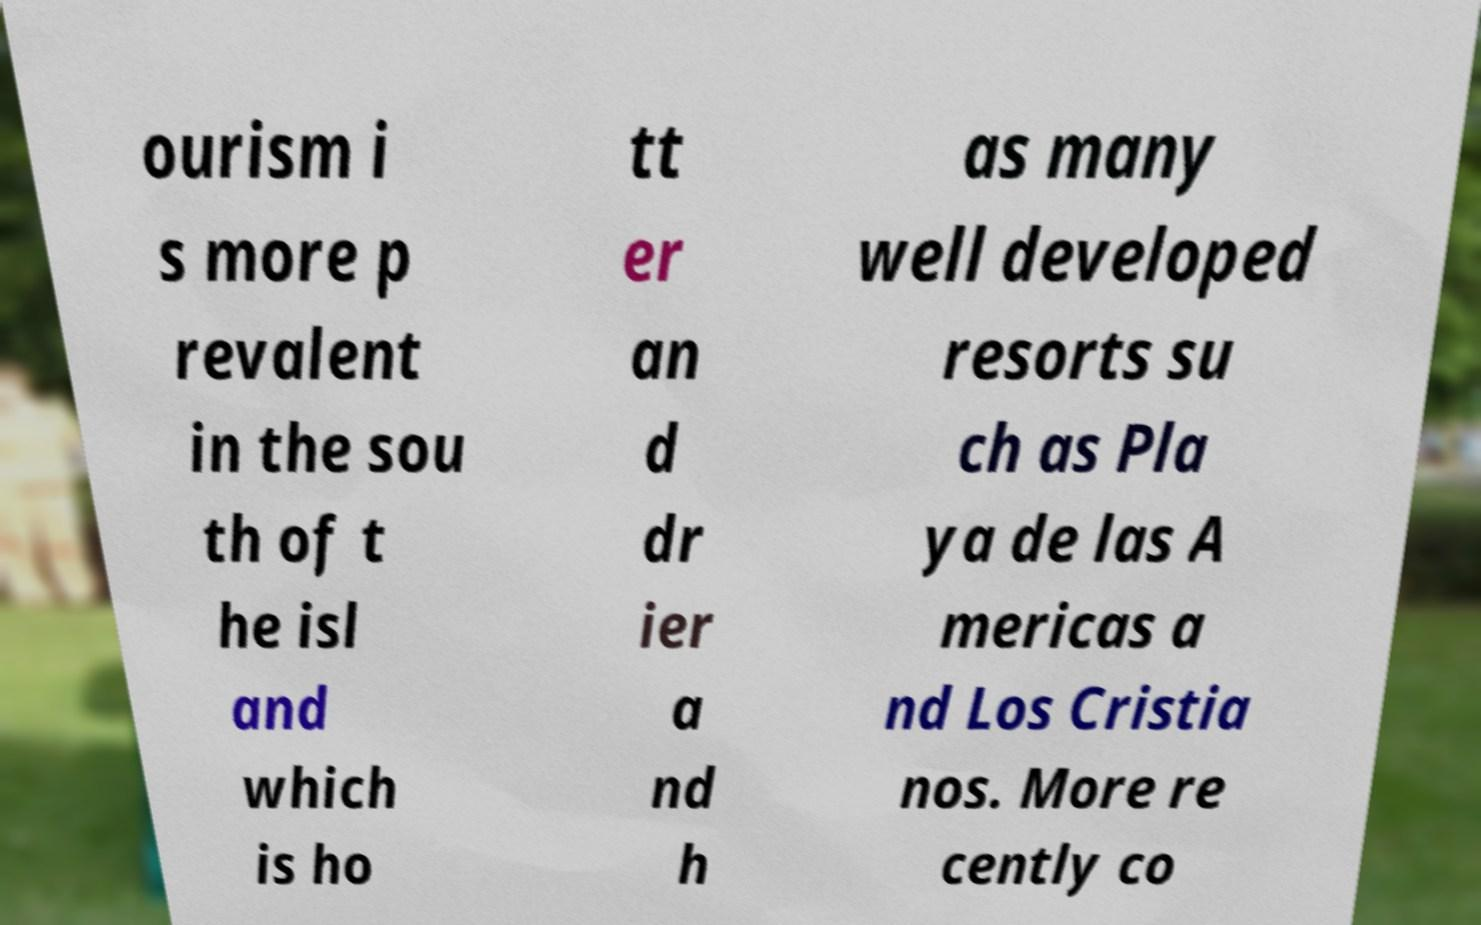Could you assist in decoding the text presented in this image and type it out clearly? ourism i s more p revalent in the sou th of t he isl and which is ho tt er an d dr ier a nd h as many well developed resorts su ch as Pla ya de las A mericas a nd Los Cristia nos. More re cently co 